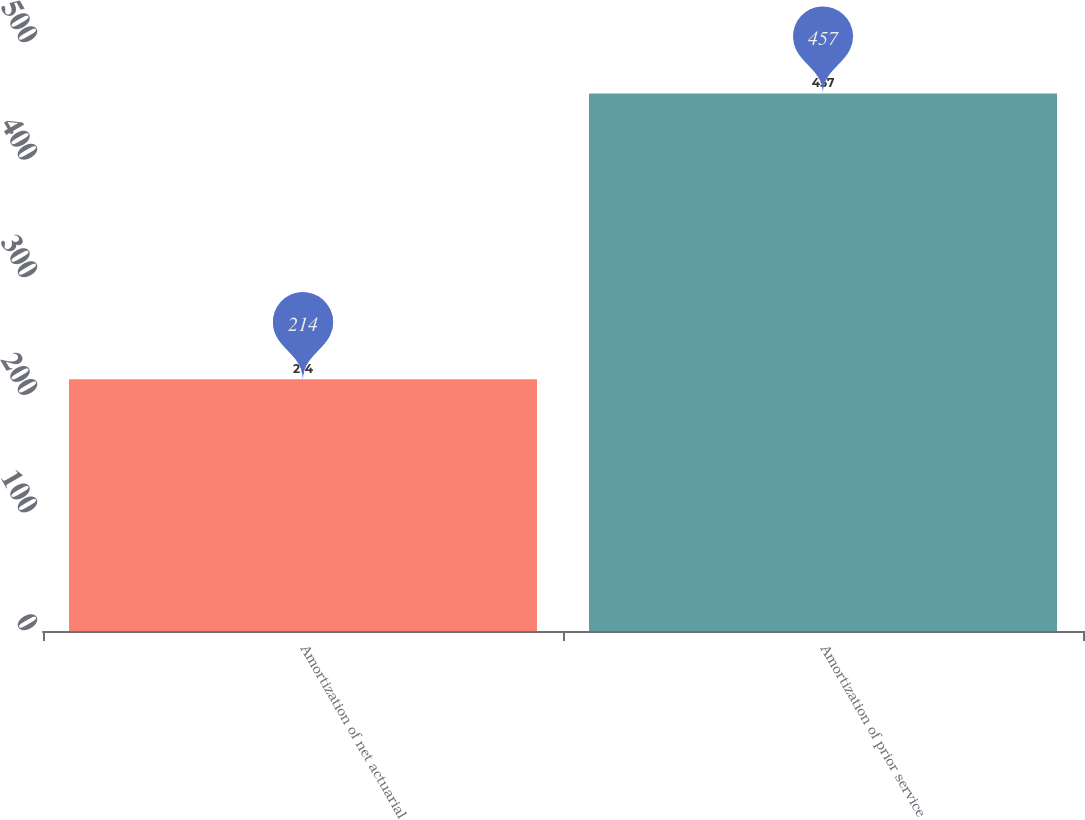Convert chart. <chart><loc_0><loc_0><loc_500><loc_500><bar_chart><fcel>Amortization of net actuarial<fcel>Amortization of prior service<nl><fcel>214<fcel>457<nl></chart> 